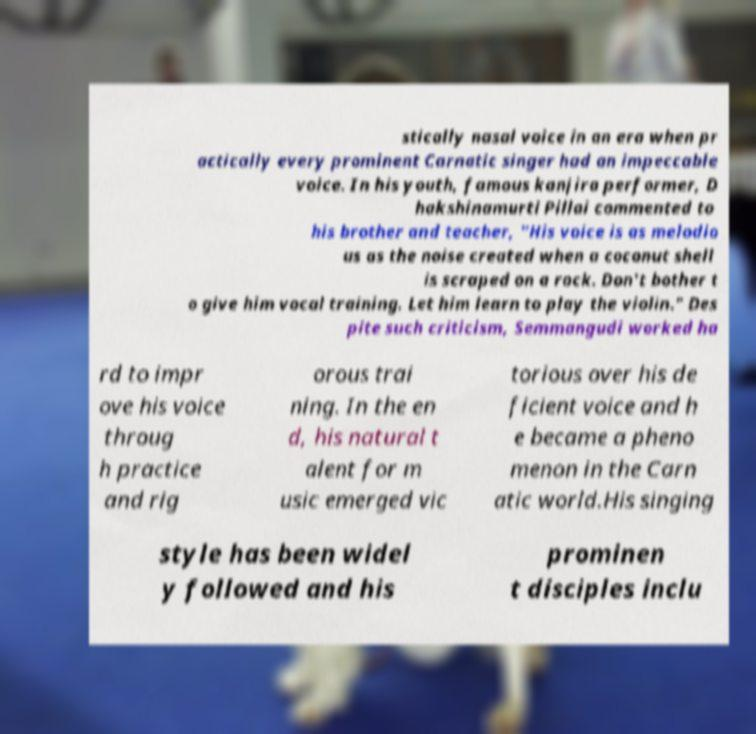Could you extract and type out the text from this image? stically nasal voice in an era when pr actically every prominent Carnatic singer had an impeccable voice. In his youth, famous kanjira performer, D hakshinamurti Pillai commented to his brother and teacher, "His voice is as melodio us as the noise created when a coconut shell is scraped on a rock. Don't bother t o give him vocal training. Let him learn to play the violin." Des pite such criticism, Semmangudi worked ha rd to impr ove his voice throug h practice and rig orous trai ning. In the en d, his natural t alent for m usic emerged vic torious over his de ficient voice and h e became a pheno menon in the Carn atic world.His singing style has been widel y followed and his prominen t disciples inclu 